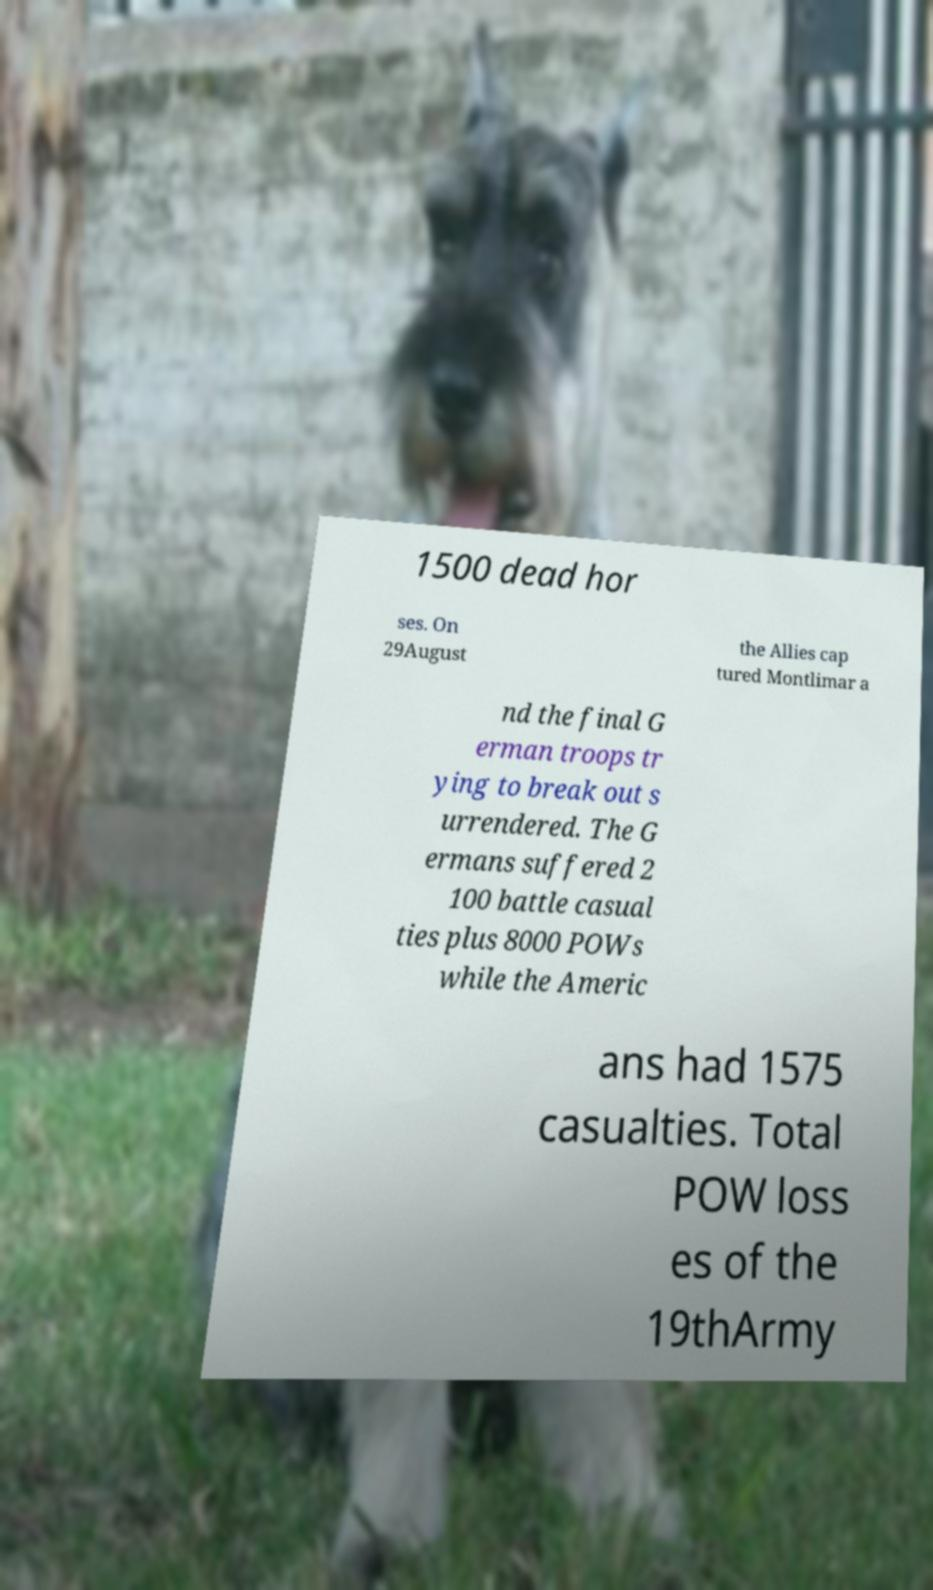Please identify and transcribe the text found in this image. 1500 dead hor ses. On 29August the Allies cap tured Montlimar a nd the final G erman troops tr ying to break out s urrendered. The G ermans suffered 2 100 battle casual ties plus 8000 POWs while the Americ ans had 1575 casualties. Total POW loss es of the 19thArmy 